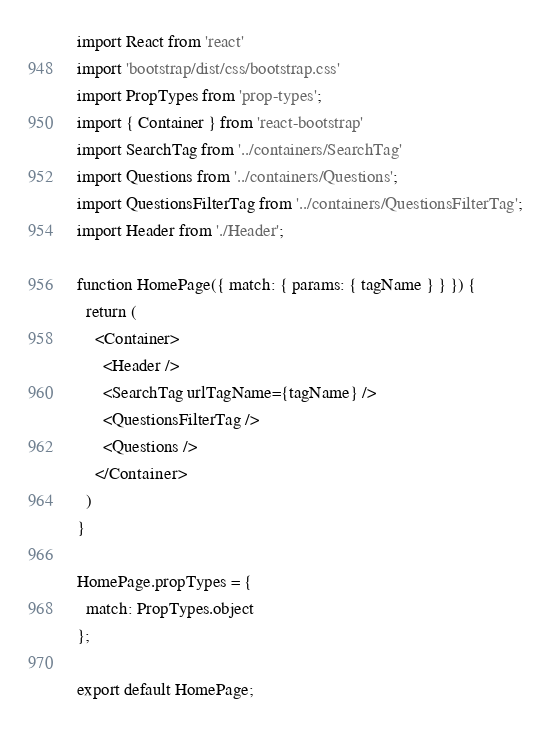Convert code to text. <code><loc_0><loc_0><loc_500><loc_500><_JavaScript_>import React from 'react'
import 'bootstrap/dist/css/bootstrap.css'
import PropTypes from 'prop-types';
import { Container } from 'react-bootstrap'
import SearchTag from '../containers/SearchTag'
import Questions from '../containers/Questions';
import QuestionsFilterTag from '../containers/QuestionsFilterTag';
import Header from './Header';

function HomePage({ match: { params: { tagName } } }) {
  return (
    <Container>
      <Header />
      <SearchTag urlTagName={tagName} />
      <QuestionsFilterTag />
      <Questions />
    </Container>
  )
}

HomePage.propTypes = {
  match: PropTypes.object
};

export default HomePage;
</code> 